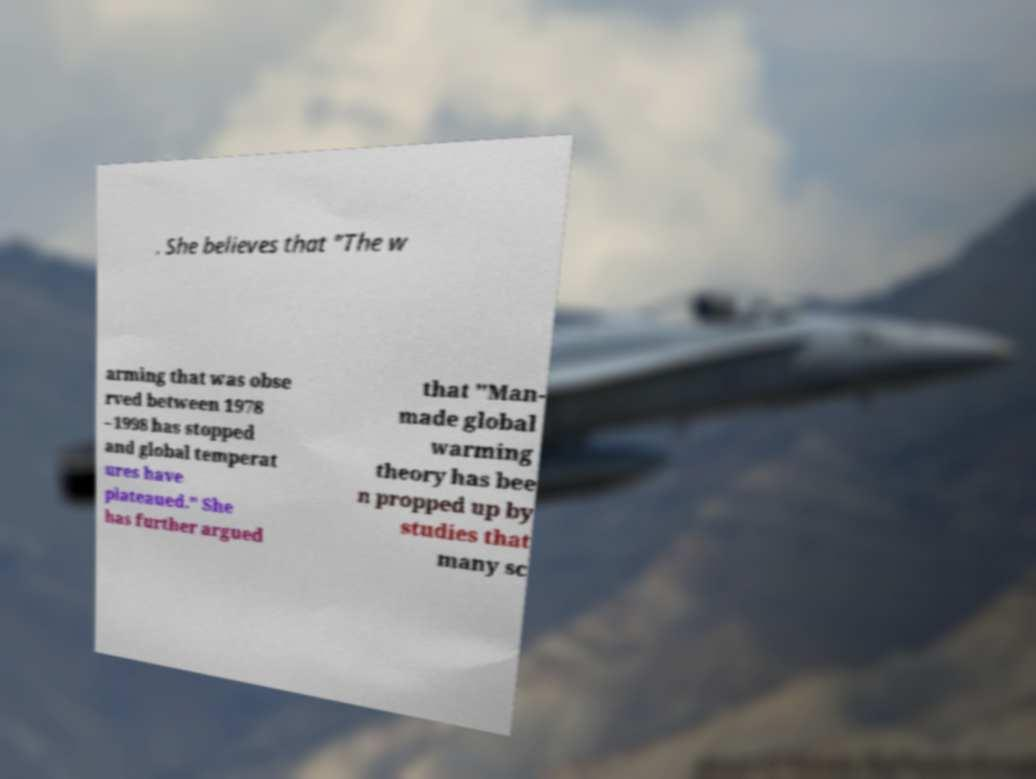Please read and relay the text visible in this image. What does it say? . She believes that "The w arming that was obse rved between 1978 –1998 has stopped and global temperat ures have plateaued." She has further argued that "Man- made global warming theory has bee n propped up by studies that many sc 